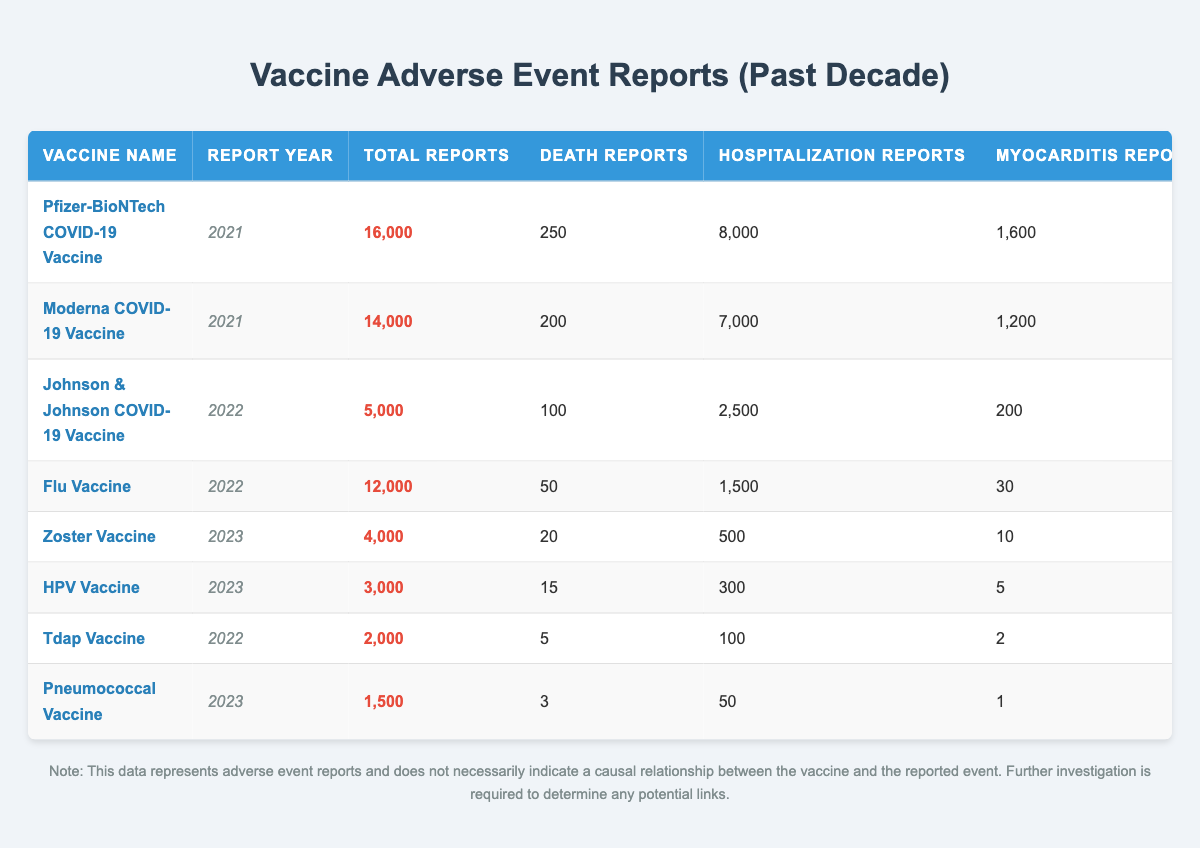What is the total number of adverse event reports for the Pfizer-BioNTech COVID-19 Vaccine in 2021? The table shows that the Pfizer-BioNTech COVID-19 Vaccine has a total of 16,000 adverse event reports in 2021.
Answer: 16,000 How many hospitalization reports were associated with the Moderna COVID-19 Vaccine in 2021? According to the table, there were 7,000 hospitalization reports for the Moderna COVID-19 Vaccine in 2021.
Answer: 7,000 Which vaccine had the highest number of death reports in 2021? Comparing the death reports for the vaccines in 2021, the Pfizer-BioNTech COVID-19 Vaccine had 250 death reports, which is the highest among the listed vaccines in that year.
Answer: Pfizer-BioNTech COVID-19 Vaccine What is the difference in total adverse event reports between the Johnson & Johnson and Flu Vaccines in 2022? The total reports for Johnson & Johnson in 2022 is 5,000 and for the Flu Vaccine, it is 12,000. The difference is 12,000 - 5,000 = 7,000.
Answer: 7,000 What percentage of the total reports for the Moderna COVID-19 Vaccine are hospitalization reports? Total reports for Moderna is 14,000. Hospitalization reports are 7,000. The percentage is (7,000 / 14,000) * 100 = 50%.
Answer: 50% How many total reports were there for vaccines in 2022? We add total reports from the vaccines in 2022: Johnson & Johnson (5,000) + Flu Vaccine (12,000) + Tdap Vaccine (2,000) = 19,000.
Answer: 19,000 In 2023, which vaccine had the lowest number of adverse event reports? In the year 2023, the Pneumococcal Vaccine had the lowest total adverse event reports at 1,500.
Answer: Pneumococcal Vaccine Which vaccine had the highest reports of myocarditis in 2021, and how many were reported? The Pfizer-BioNTech COVID-19 Vaccine had the highest myocarditis reports in 2021 with 1,600 cases.
Answer: Pfizer-BioNTech COVID-19 Vaccine, 1,600 Is it true that the total reports for the Zoster Vaccine in 2023 is less than that of the Flu Vaccine in 2022? Yes, the Zoster Vaccine had 4,000 total reports in 2023, while the Flu Vaccine had 12,000 in 2022, so this statement is true.
Answer: Yes Calculate the average number of death reports across all vaccines listed. Adding the death reports: 250 + 200 + 100 + 50 + 20 + 15 + 5 + 3 = 643. There are 8 vaccines in total, so the average is 643 / 8 = 80.375, which can be approximated to 80 when considering whole numbers.
Answer: 80 